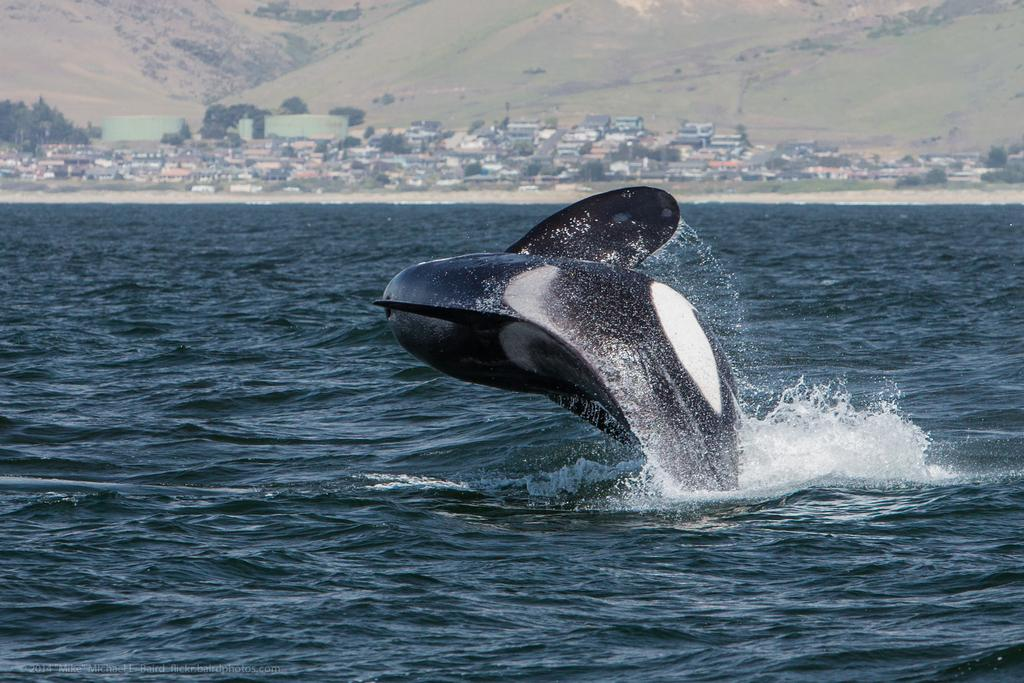What animal is featured in the image? There is a dolphin in the image. What is the dolphin doing in the image? The dolphin is jumping into the sea. What can be seen in the background of the image? There are trees and buildings in the background of the image. What type of landscape is visible at the top of the image? There are hills visible at the top of the image. What type of mint plant can be seen growing in the yard in the image? There is no mint plant or yard present in the image; it features a dolphin jumping into the sea with a background of trees, buildings, and hills. 